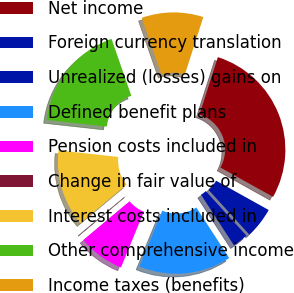<chart> <loc_0><loc_0><loc_500><loc_500><pie_chart><fcel>Net income<fcel>Foreign currency translation<fcel>Unrealized (losses) gains on<fcel>Defined benefit plans<fcel>Pension costs included in<fcel>Change in fair value of<fcel>Interest costs included in<fcel>Other comprehensive income<fcel>Income taxes (benefits)<nl><fcel>28.15%<fcel>5.15%<fcel>2.59%<fcel>15.37%<fcel>7.7%<fcel>0.03%<fcel>12.82%<fcel>17.93%<fcel>10.26%<nl></chart> 